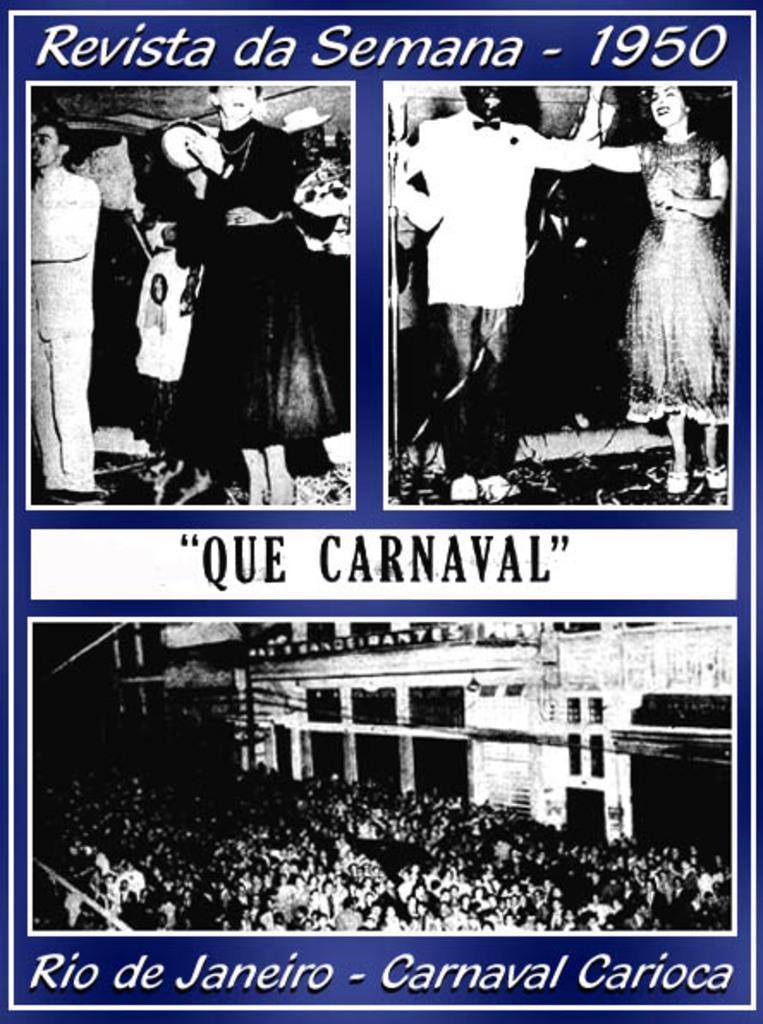Can you describe this image briefly? There is a poster having three images, In these images there are persons and there are texts and numbers. And the background is violet in color. 